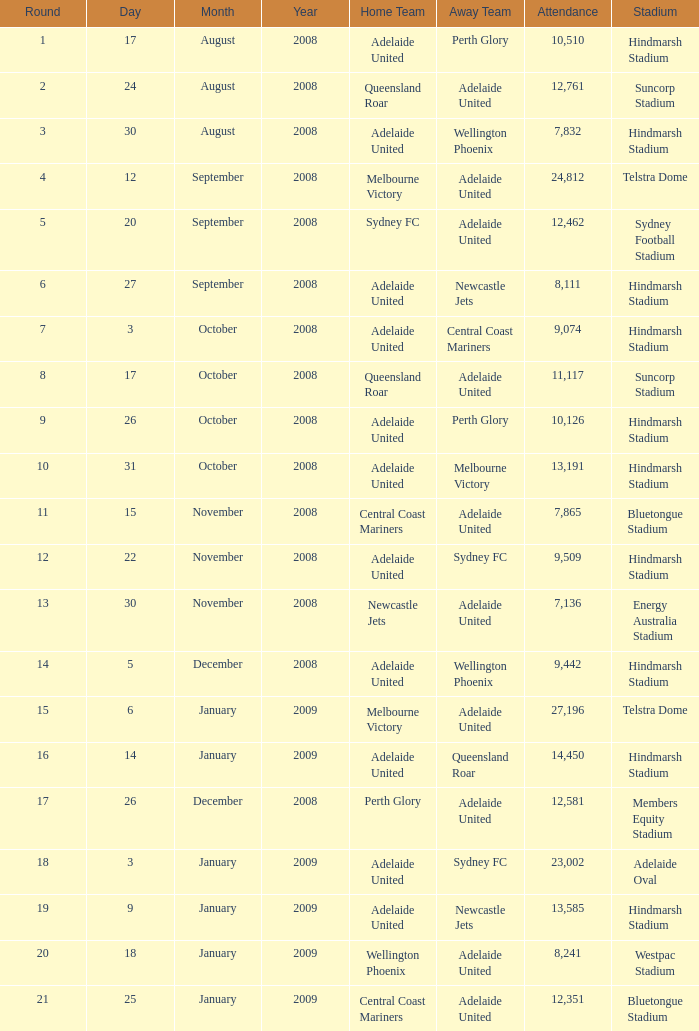Who was the away team when Queensland Roar was the home team in the round less than 3? Adelaide United. 